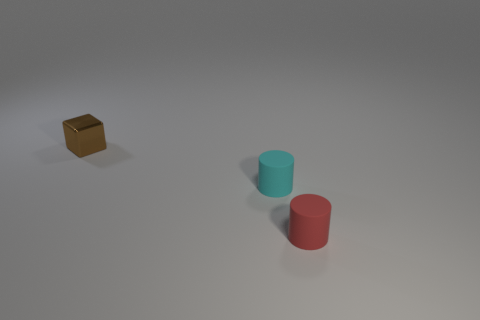What number of other cyan objects are the same shape as the tiny cyan object?
Give a very brief answer. 0. How many tiny brown objects are there?
Keep it short and to the point. 1. What is the size of the thing that is both behind the red object and to the right of the brown shiny block?
Give a very brief answer. Small. What shape is the metallic thing that is the same size as the red matte object?
Make the answer very short. Cube. Are there any small red objects behind the cylinder that is to the right of the small cyan cylinder?
Provide a short and direct response. No. There is another small object that is the same shape as the tiny cyan matte thing; what color is it?
Your answer should be very brief. Red. Is the color of the thing in front of the cyan matte object the same as the metal block?
Your response must be concise. No. How many objects are either matte things that are on the left side of the small red rubber thing or small green things?
Make the answer very short. 1. There is a cylinder that is behind the rubber thing that is to the right of the matte thing left of the tiny red rubber thing; what is its material?
Give a very brief answer. Rubber. Are there more red rubber things that are to the left of the cyan thing than tiny blocks on the left side of the brown shiny cube?
Your answer should be very brief. No. 